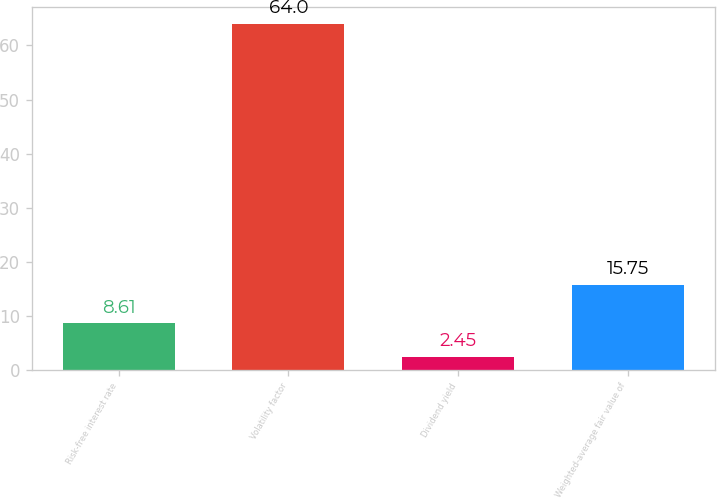<chart> <loc_0><loc_0><loc_500><loc_500><bar_chart><fcel>Risk-free interest rate<fcel>Volatility factor<fcel>Dividend yield<fcel>Weighted-average fair value of<nl><fcel>8.61<fcel>64<fcel>2.45<fcel>15.75<nl></chart> 